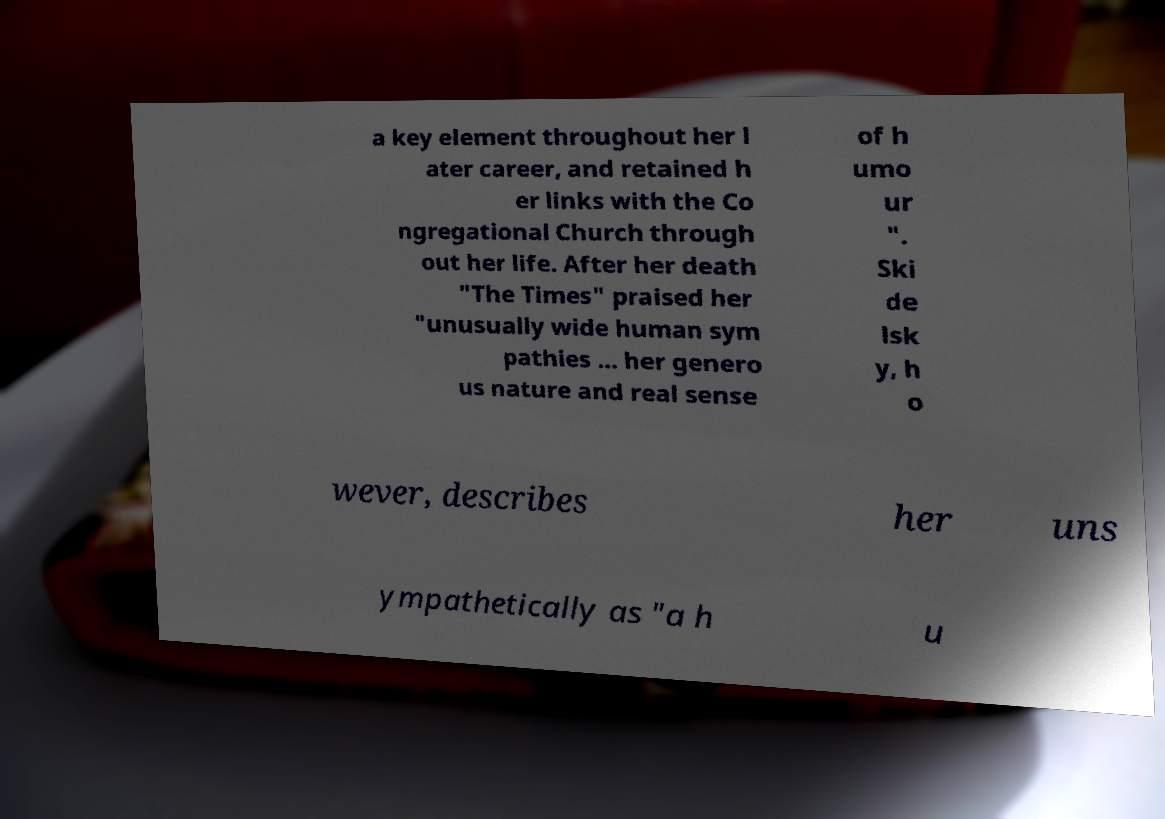Can you read and provide the text displayed in the image?This photo seems to have some interesting text. Can you extract and type it out for me? a key element throughout her l ater career, and retained h er links with the Co ngregational Church through out her life. After her death "The Times" praised her "unusually wide human sym pathies ... her genero us nature and real sense of h umo ur ". Ski de lsk y, h o wever, describes her uns ympathetically as "a h u 